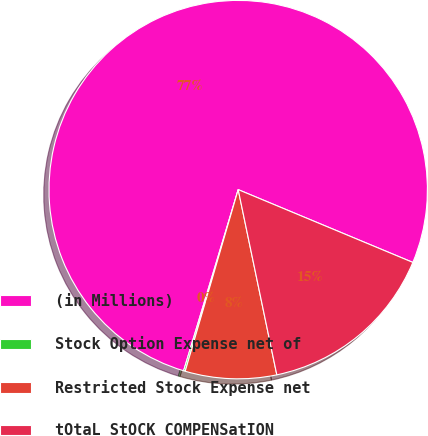Convert chart to OTSL. <chart><loc_0><loc_0><loc_500><loc_500><pie_chart><fcel>(in Millions)<fcel>Stock Option Expense net of<fcel>Restricted Stock Expense net<fcel>tOtaL StOCK COMPENSatION<nl><fcel>76.62%<fcel>0.14%<fcel>7.79%<fcel>15.44%<nl></chart> 